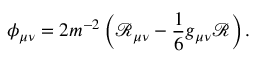Convert formula to latex. <formula><loc_0><loc_0><loc_500><loc_500>\phi _ { \mu \nu } = 2 m ^ { - 2 } \left ( \mathcal { R } _ { \mu \nu } - \frac { 1 } { 6 } g _ { \mu \nu } \mathcal { R } \right ) .</formula> 